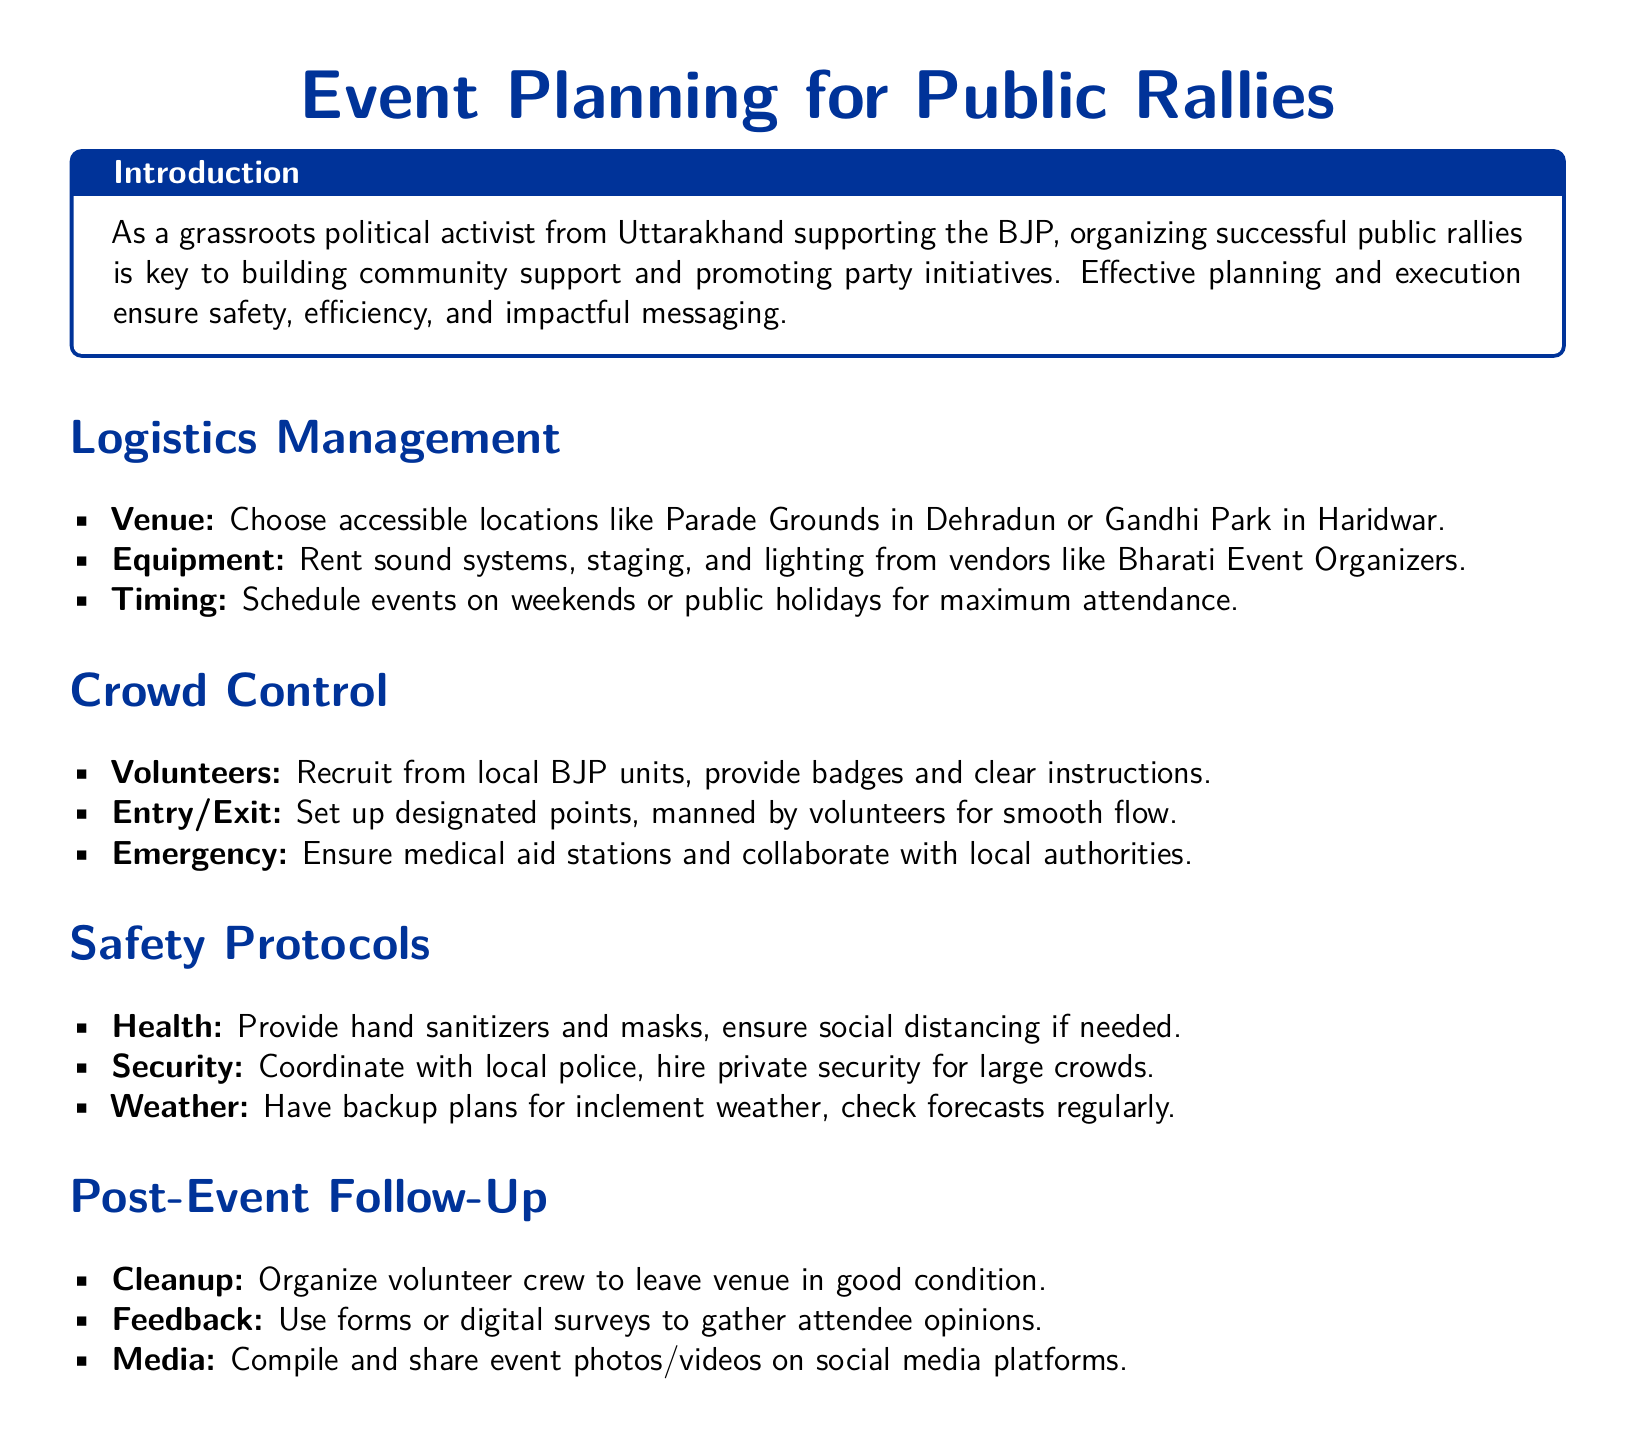What is the title of the document? The title is specifically stated at the beginning of the document.
Answer: Event Planning for Public Rallies What is the primary focus of the introduction? The introduction outlines the role of rallies for grassroots activists and emphasizes the importance of effective planning.
Answer: Organizing successful public rallies Which location is suggested for the venue in Dehradun? The document lists specific locations for organizing events, which serve as examples for venue selection.
Answer: Parade Grounds What type of personal protective equipment is mentioned in the safety protocols? The safety section provides details on health measures to be implemented at the events.
Answer: Masks Who should be recruited for crowd control? The document specifies the source of volunteers required for managing attendees during the rally.
Answer: Local BJP units What should be organized by volunteers after the event? The document mentions a specific task to be performed post-event for environmental considerations.
Answer: Cleanup How can feedback be gathered from attendees? The document outlines methods for collecting opinions from participants after the event.
Answer: Digital surveys What should be done if there is inclement weather? A precautionary measure for unexpected weather conditions is indicated in the safety protocols section.
Answer: Backup plans What is a key logistical element to consider for timing? The document suggests a specific time frame to maximize attendance at public rallies.
Answer: Weekends or public holidays 